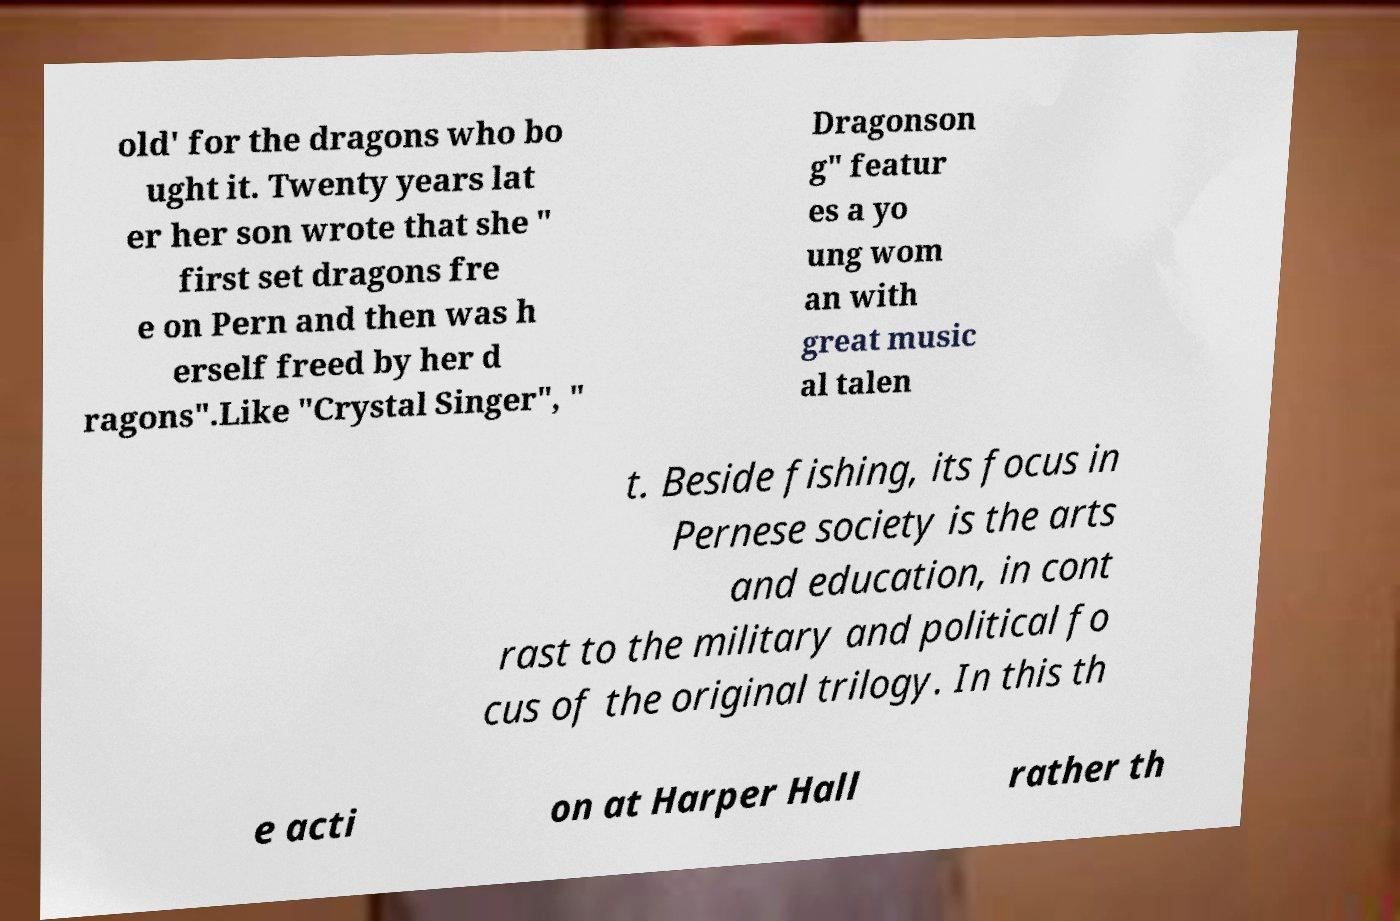Please read and relay the text visible in this image. What does it say? old' for the dragons who bo ught it. Twenty years lat er her son wrote that she " first set dragons fre e on Pern and then was h erself freed by her d ragons".Like "Crystal Singer", " Dragonson g" featur es a yo ung wom an with great music al talen t. Beside fishing, its focus in Pernese society is the arts and education, in cont rast to the military and political fo cus of the original trilogy. In this th e acti on at Harper Hall rather th 